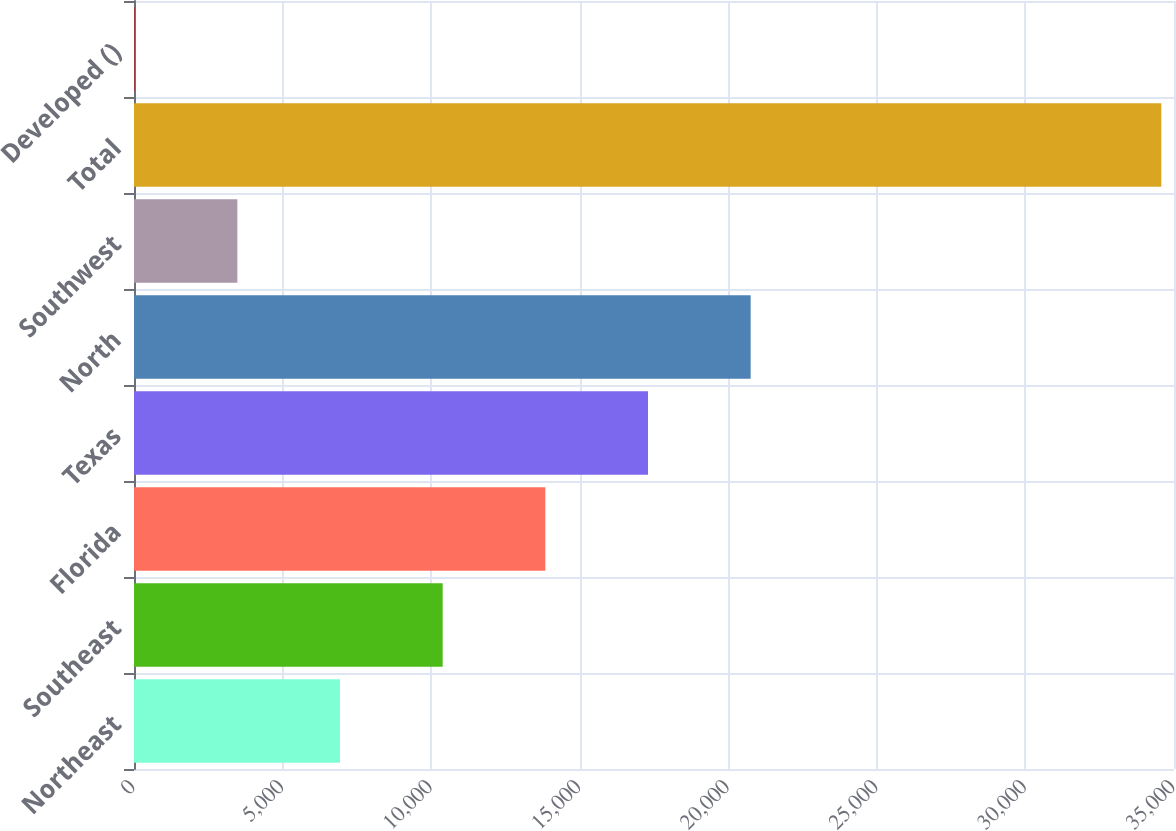<chart> <loc_0><loc_0><loc_500><loc_500><bar_chart><fcel>Northeast<fcel>Southeast<fcel>Florida<fcel>Texas<fcel>North<fcel>Southwest<fcel>Total<fcel>Developed ()<nl><fcel>6933<fcel>10388<fcel>13843<fcel>17298<fcel>20753<fcel>3478<fcel>34573<fcel>23<nl></chart> 